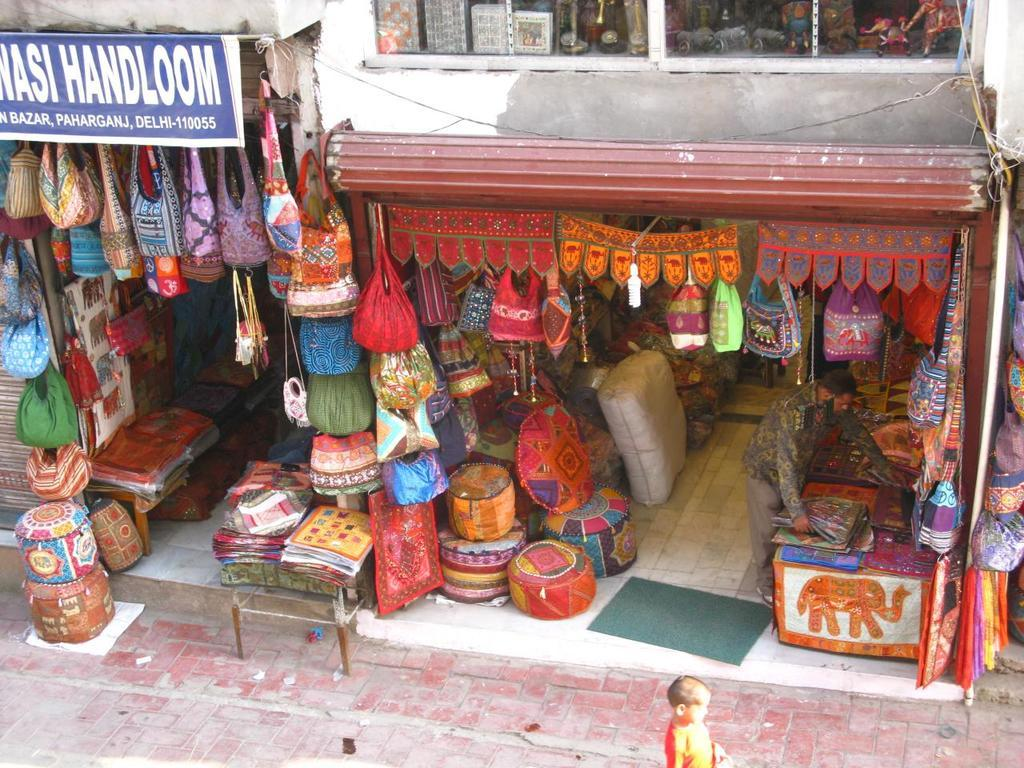<image>
Relay a brief, clear account of the picture shown. A store selling stitched goods and a sign with foreign writing. 